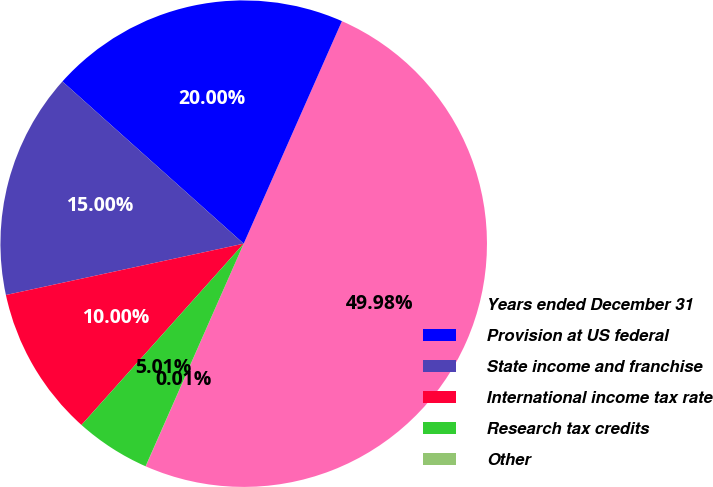Convert chart. <chart><loc_0><loc_0><loc_500><loc_500><pie_chart><fcel>Years ended December 31<fcel>Provision at US federal<fcel>State income and franchise<fcel>International income tax rate<fcel>Research tax credits<fcel>Other<nl><fcel>49.98%<fcel>20.0%<fcel>15.0%<fcel>10.0%<fcel>5.01%<fcel>0.01%<nl></chart> 